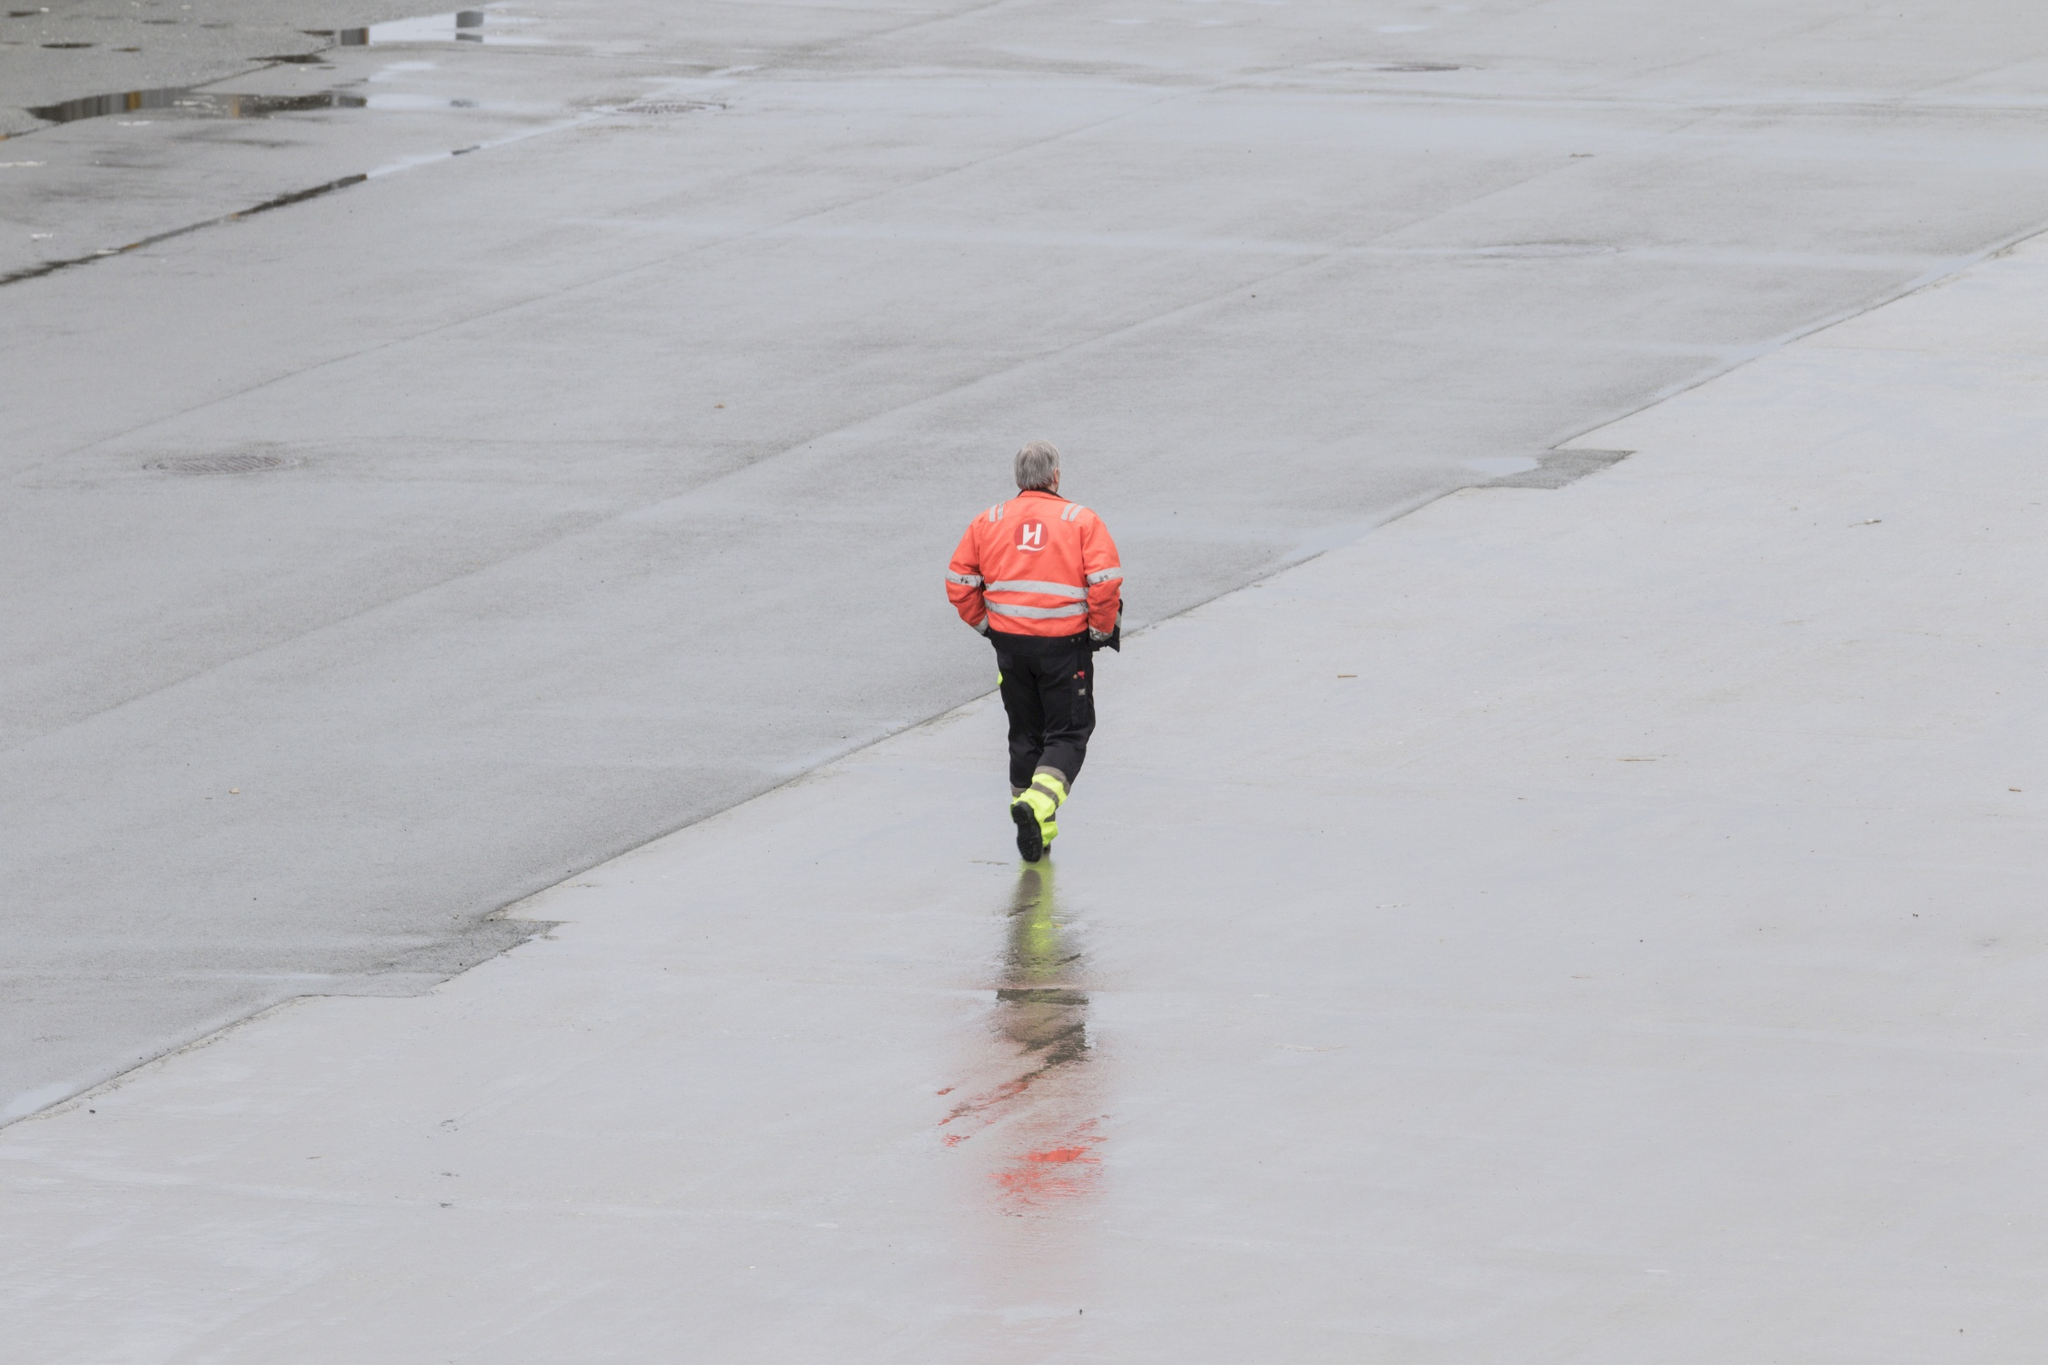Why do you think the person is wearing a high-visibility vest? The high-visibility vest with reflective stripes is typically worn for safety purposes, making the individual easily noticeable in various environments. It's commonly used in construction, maintenance, and emergency services. In this case, it suggests the person might be working in an area where visibility is crucial for safety, such as near vehicular traffic or at a site where it is important to be seen by other workers.  Could the red streak on the ground indicate some kind of emergency? The red streak could be indicative of an emergency situation, such as a spill or leak that requires immediate attention, or it might be a painted line for construction or zoning purposes. The person's focused approach towards the streak hints that they are investigating or dealing with the situation. The exact circumstances, however, cannot be determined solely from the image. 